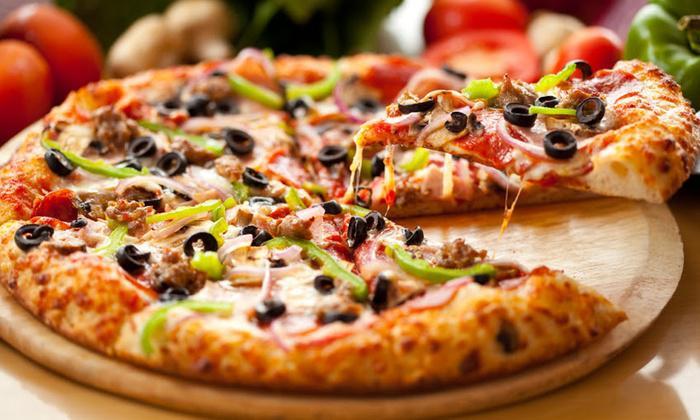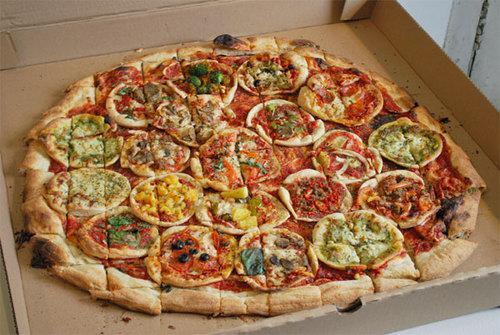The first image is the image on the left, the second image is the image on the right. Evaluate the accuracy of this statement regarding the images: "One slice of pizza is being separated from the rest.". Is it true? Answer yes or no. Yes. The first image is the image on the left, the second image is the image on the right. For the images shown, is this caption "A whole pizza is on a pizza box in the right image." true? Answer yes or no. Yes. 